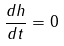<formula> <loc_0><loc_0><loc_500><loc_500>\frac { d h } { d t } = 0</formula> 